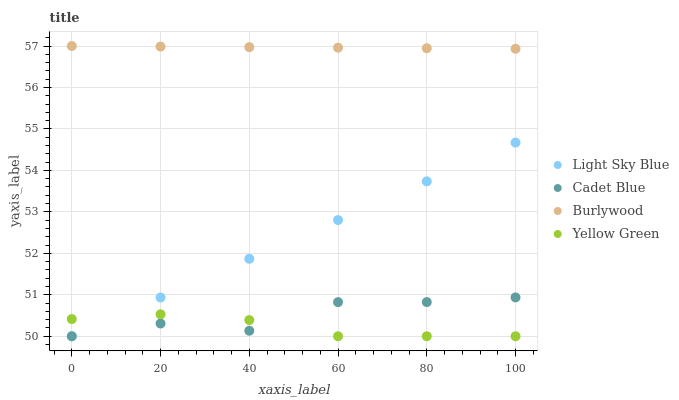Does Yellow Green have the minimum area under the curve?
Answer yes or no. Yes. Does Burlywood have the maximum area under the curve?
Answer yes or no. Yes. Does Light Sky Blue have the minimum area under the curve?
Answer yes or no. No. Does Light Sky Blue have the maximum area under the curve?
Answer yes or no. No. Is Light Sky Blue the smoothest?
Answer yes or no. Yes. Is Cadet Blue the roughest?
Answer yes or no. Yes. Is Burlywood the smoothest?
Answer yes or no. No. Is Burlywood the roughest?
Answer yes or no. No. Does Cadet Blue have the lowest value?
Answer yes or no. Yes. Does Burlywood have the lowest value?
Answer yes or no. No. Does Burlywood have the highest value?
Answer yes or no. Yes. Does Light Sky Blue have the highest value?
Answer yes or no. No. Is Yellow Green less than Burlywood?
Answer yes or no. Yes. Is Burlywood greater than Light Sky Blue?
Answer yes or no. Yes. Does Cadet Blue intersect Yellow Green?
Answer yes or no. Yes. Is Cadet Blue less than Yellow Green?
Answer yes or no. No. Is Cadet Blue greater than Yellow Green?
Answer yes or no. No. Does Yellow Green intersect Burlywood?
Answer yes or no. No. 